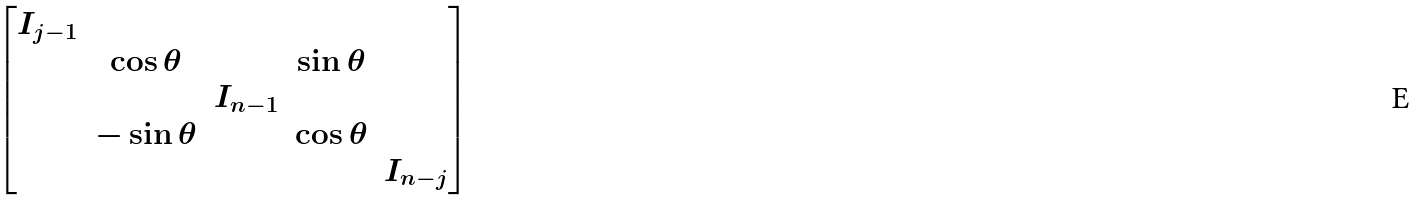Convert formula to latex. <formula><loc_0><loc_0><loc_500><loc_500>\begin{bmatrix} I _ { j - 1 } \\ & \cos \theta & & \sin \theta \\ & & I _ { n - 1 } \\ & - \sin \theta & & \cos \theta \\ & & & & I _ { n - j } \end{bmatrix}</formula> 